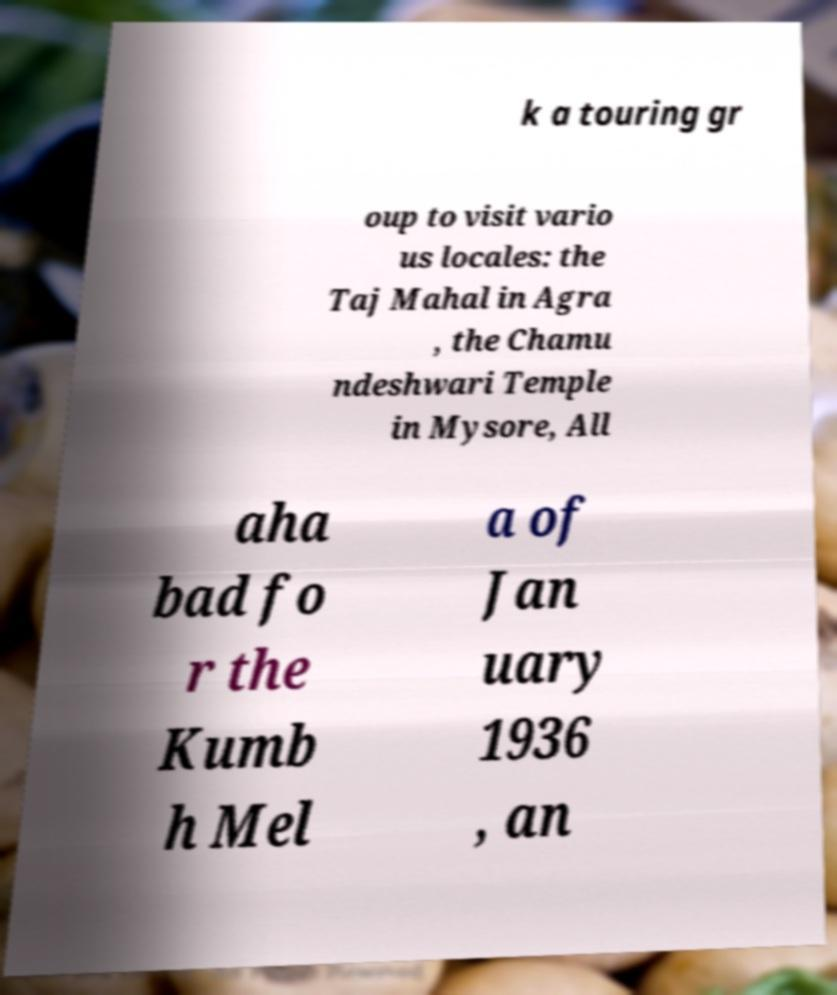Can you accurately transcribe the text from the provided image for me? k a touring gr oup to visit vario us locales: the Taj Mahal in Agra , the Chamu ndeshwari Temple in Mysore, All aha bad fo r the Kumb h Mel a of Jan uary 1936 , an 